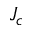Convert formula to latex. <formula><loc_0><loc_0><loc_500><loc_500>J _ { c }</formula> 